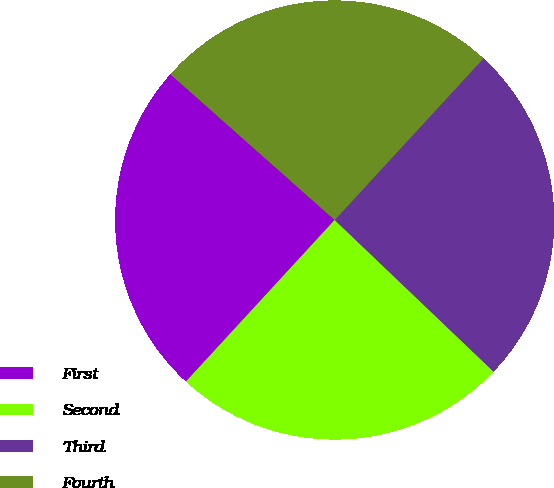Convert chart. <chart><loc_0><loc_0><loc_500><loc_500><pie_chart><fcel>First<fcel>Second<fcel>Third<fcel>Fourth<nl><fcel>24.71%<fcel>24.71%<fcel>25.29%<fcel>25.29%<nl></chart> 